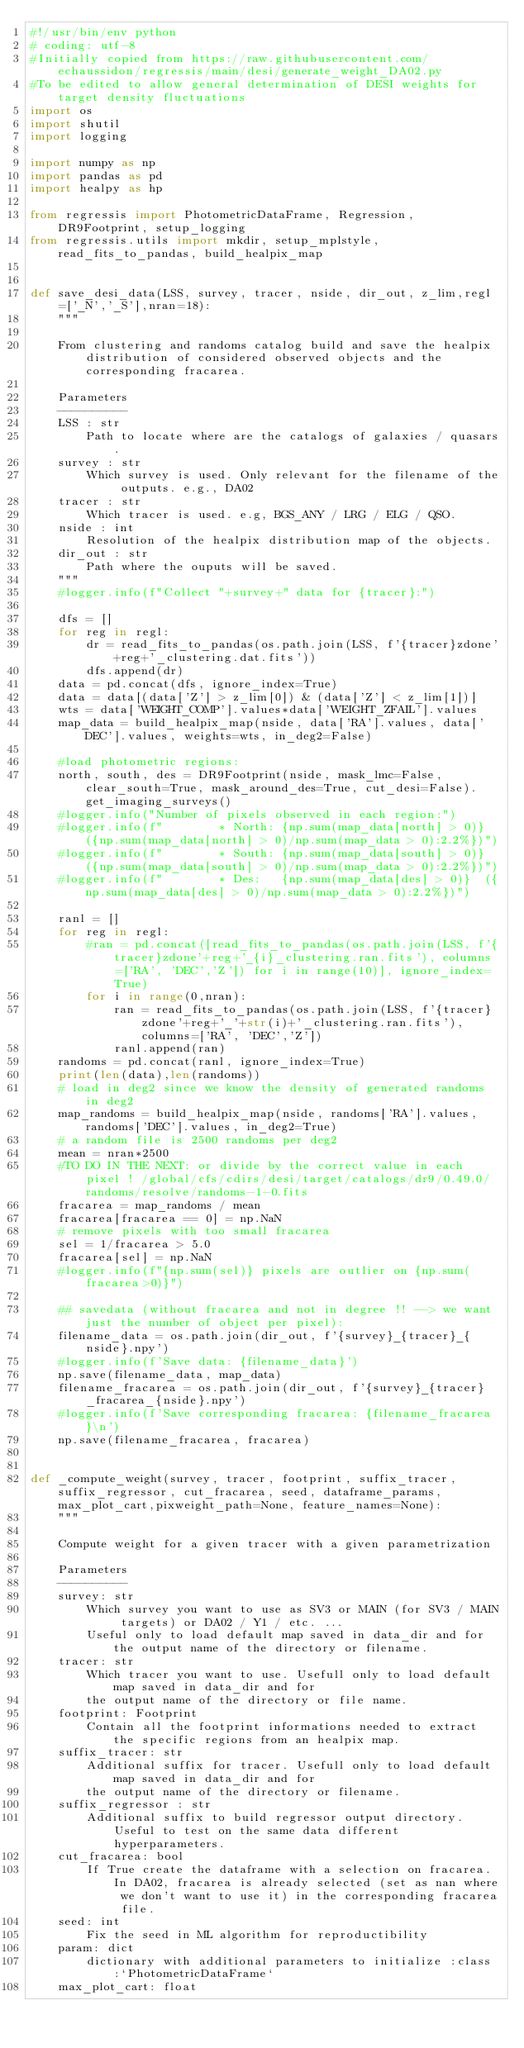Convert code to text. <code><loc_0><loc_0><loc_500><loc_500><_Python_>#!/usr/bin/env python
# coding: utf-8
#Initially copied from https://raw.githubusercontent.com/echaussidon/regressis/main/desi/generate_weight_DA02.py
#To be edited to allow general determination of DESI weights for target density fluctuations
import os
import shutil
import logging

import numpy as np
import pandas as pd
import healpy as hp

from regressis import PhotometricDataFrame, Regression, DR9Footprint, setup_logging
from regressis.utils import mkdir, setup_mplstyle, read_fits_to_pandas, build_healpix_map


def save_desi_data(LSS, survey, tracer, nside, dir_out, z_lim,regl=['_N','_S'],nran=18):
    """
    
    From clustering and randoms catalog build and save the healpix distribution of considered observed objects and the corresponding fracarea. 
    
    Parameters
    ----------
    LSS : str
        Path to locate where are the catalogs of galaxies / quasars.
    survey : str
        Which survey is used. Only relevant for the filename of the outputs. e.g., DA02 
    tracer : str
        Which tracer is used. e.g, BGS_ANY / LRG / ELG / QSO.
    nside : int
        Resolution of the healpix distribution map of the objects.
    dir_out : str
        Path where the ouputs will be saved.
    """
    #logger.info(f"Collect "+survey+" data for {tracer}:")

    dfs = []
    for reg in regl:
        dr = read_fits_to_pandas(os.path.join(LSS, f'{tracer}zdone'+reg+'_clustering.dat.fits'))
        dfs.append(dr)
    data = pd.concat(dfs, ignore_index=True)
    data = data[(data['Z'] > z_lim[0]) & (data['Z'] < z_lim[1])]
    wts = data['WEIGHT_COMP'].values*data['WEIGHT_ZFAIL'].values
    map_data = build_healpix_map(nside, data['RA'].values, data['DEC'].values, weights=wts, in_deg2=False)

    #load photometric regions:
    north, south, des = DR9Footprint(nside, mask_lmc=False, clear_south=True, mask_around_des=True, cut_desi=False).get_imaging_surveys()
    #logger.info("Number of pixels observed in each region:")
    #logger.info(f"        * North: {np.sum(map_data[north] > 0)} ({np.sum(map_data[north] > 0)/np.sum(map_data > 0):2.2%})")
    #logger.info(f"        * South: {np.sum(map_data[south] > 0)} ({np.sum(map_data[south] > 0)/np.sum(map_data > 0):2.2%})")
    #logger.info(f"        * Des:   {np.sum(map_data[des] > 0)}  ({np.sum(map_data[des] > 0)/np.sum(map_data > 0):2.2%})")

    ranl = []
    for reg in regl:
        #ran = pd.concat([read_fits_to_pandas(os.path.join(LSS, f'{tracer}zdone'+reg+'_{i}_clustering.ran.fits'), columns=['RA', 'DEC','Z']) for i in range(10)], ignore_index=True)
        for i in range(0,nran):
            ran = read_fits_to_pandas(os.path.join(LSS, f'{tracer}zdone'+reg+'_'+str(i)+'_clustering.ran.fits'), columns=['RA', 'DEC','Z']) 
            ranl.append(ran)
    randoms = pd.concat(ranl, ignore_index=True)
    print(len(data),len(randoms))
    # load in deg2 since we know the density of generated randoms in deg2
    map_randoms = build_healpix_map(nside, randoms['RA'].values, randoms['DEC'].values, in_deg2=True)
    # a random file is 2500 randoms per deg2
    mean = nran*2500
    #TO DO IN THE NEXT: or divide by the correct value in each pixel ! /global/cfs/cdirs/desi/target/catalogs/dr9/0.49.0/randoms/resolve/randoms-1-0.fits
    fracarea = map_randoms / mean
    fracarea[fracarea == 0] = np.NaN
    # remove pixels with too small fracarea
    sel = 1/fracarea > 5.0
    fracarea[sel] = np.NaN
    #logger.info(f"{np.sum(sel)} pixels are outlier on {np.sum(fracarea>0)}")

    ## savedata (without fracarea and not in degree !! --> we want just the number of object per pixel):
    filename_data = os.path.join(dir_out, f'{survey}_{tracer}_{nside}.npy')
    #logger.info(f'Save data: {filename_data}')
    np.save(filename_data, map_data)
    filename_fracarea = os.path.join(dir_out, f'{survey}_{tracer}_fracarea_{nside}.npy')
    #logger.info(f'Save corresponding fracarea: {filename_fracarea}\n')
    np.save(filename_fracarea, fracarea)


def _compute_weight(survey, tracer, footprint, suffix_tracer, suffix_regressor, cut_fracarea, seed, dataframe_params, max_plot_cart,pixweight_path=None, feature_names=None):
    """

    Compute weight for a given tracer with a given parametrization

    Parameters
    ----------
    survey: str
        Which survey you want to use as SV3 or MAIN (for SV3 / MAIN targets) or DA02 / Y1 / etc. ...
        Useful only to load default map saved in data_dir and for the output name of the directory or filename.
    tracer: str
        Which tracer you want to use. Usefull only to load default map saved in data_dir and for
        the output name of the directory or file name.
    footprint: Footprint
        Contain all the footprint informations needed to extract the specific regions from an healpix map.
    suffix_tracer: str
        Additional suffix for tracer. Usefull only to load default map saved in data_dir and for
        the output name of the directory or filename.
    suffix_regressor : str
        Additional suffix to build regressor output directory. Useful to test on the same data different hyperparameters.
    cut_fracarea: bool
        If True create the dataframe with a selection on fracarea. In DA02, fracarea is already selected (set as nan where we don't want to use it) in the corresponding fracarea file.
    seed: int
        Fix the seed in ML algorithm for reproductibility
    param: dict
        dictionary with additional parameters to initialize :class:`PhotometricDataFrame`
    max_plot_cart: float</code> 